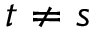<formula> <loc_0><loc_0><loc_500><loc_500>t \neq s</formula> 